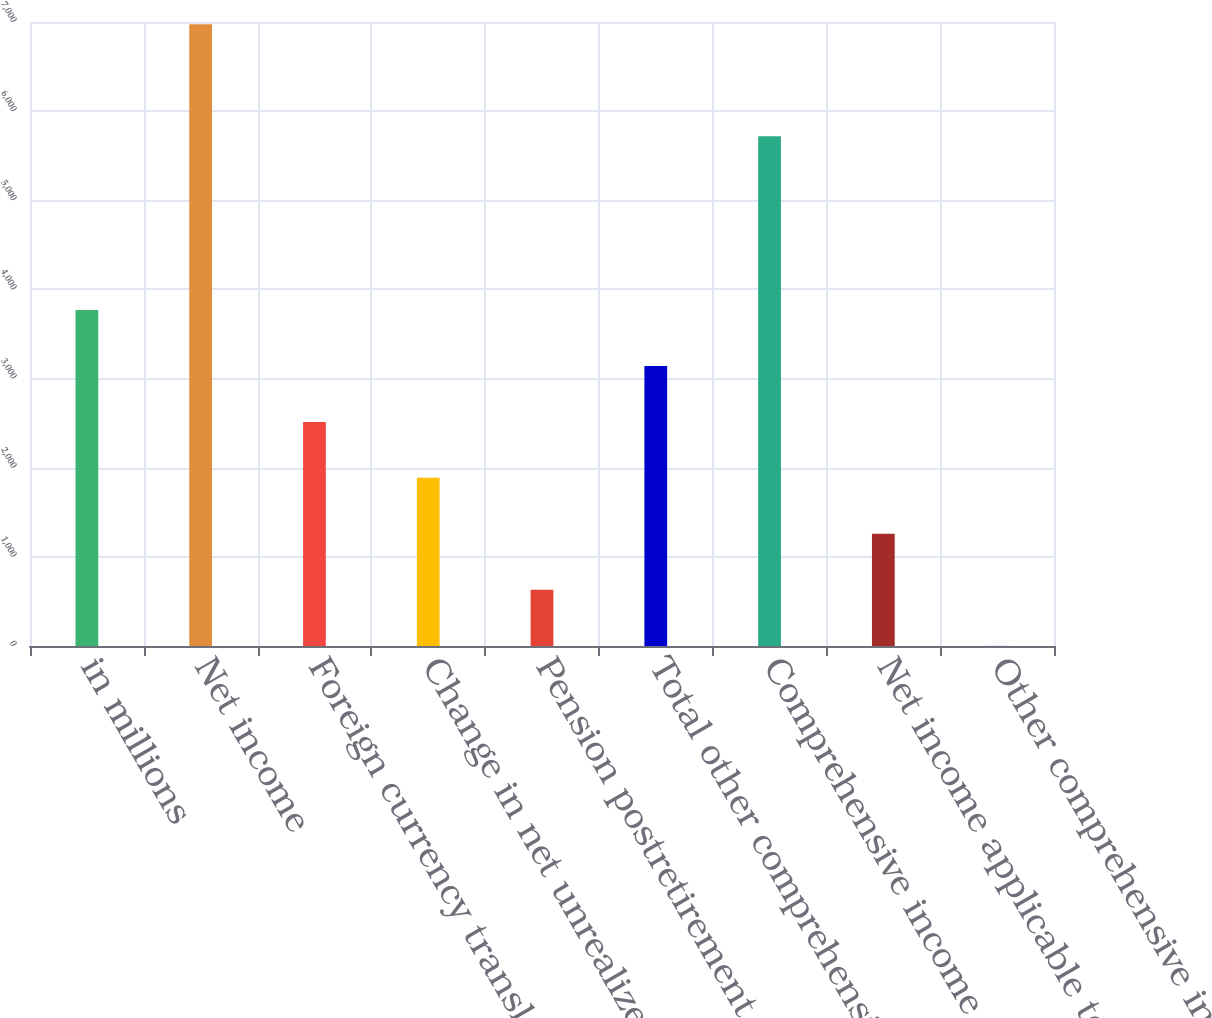Convert chart. <chart><loc_0><loc_0><loc_500><loc_500><bar_chart><fcel>in millions<fcel>Net income<fcel>Foreign currency translation<fcel>Change in net unrealized gains<fcel>Pension postretirement and<fcel>Total other comprehensive<fcel>Comprehensive income<fcel>Net income applicable to<fcel>Other comprehensive income<nl><fcel>3769<fcel>6974<fcel>2514<fcel>1886.5<fcel>631.5<fcel>3141.5<fcel>5719<fcel>1259<fcel>4<nl></chart> 